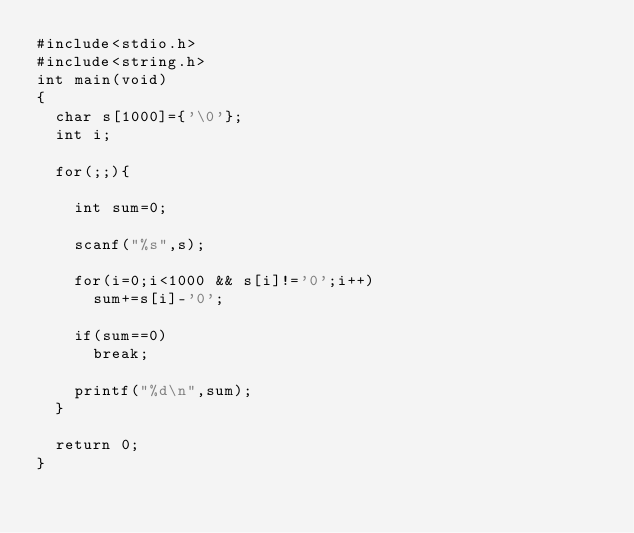<code> <loc_0><loc_0><loc_500><loc_500><_C_>#include<stdio.h>
#include<string.h>
int main(void)
{
  char s[1000]={'\0'};
  int i;

  for(;;){

    int sum=0;

    scanf("%s",s);

    for(i=0;i<1000 && s[i]!='0';i++)
      sum+=s[i]-'0';

    if(sum==0)
      break;

    printf("%d\n",sum);
  }

  return 0;
}</code> 